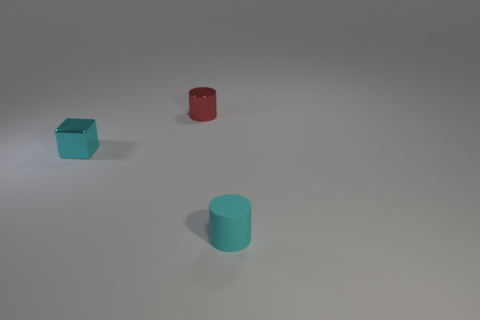There is a red cylinder behind the cyan matte object; what number of tiny rubber objects are to the left of it?
Keep it short and to the point. 0. Is the material of the tiny object in front of the small cyan shiny cube the same as the small cyan object on the left side of the small red metallic cylinder?
Your response must be concise. No. How many small cyan matte things are the same shape as the tiny red thing?
Your answer should be compact. 1. How many tiny objects are the same color as the cube?
Give a very brief answer. 1. Do the tiny object to the right of the red cylinder and the shiny object that is behind the cyan block have the same shape?
Ensure brevity in your answer.  Yes. What number of cyan metal objects are right of the small cylinder left of the small rubber object in front of the tiny cube?
Your response must be concise. 0. What is the cyan thing that is left of the cylinder that is behind the object that is right of the shiny cylinder made of?
Ensure brevity in your answer.  Metal. Are the small cylinder that is behind the block and the small cyan block made of the same material?
Your answer should be very brief. Yes. How many other metallic things are the same size as the red shiny thing?
Provide a succinct answer. 1. Is the number of tiny cyan cubes that are to the left of the tiny metallic block greater than the number of cyan rubber cylinders that are behind the small cyan matte cylinder?
Your answer should be compact. No. 